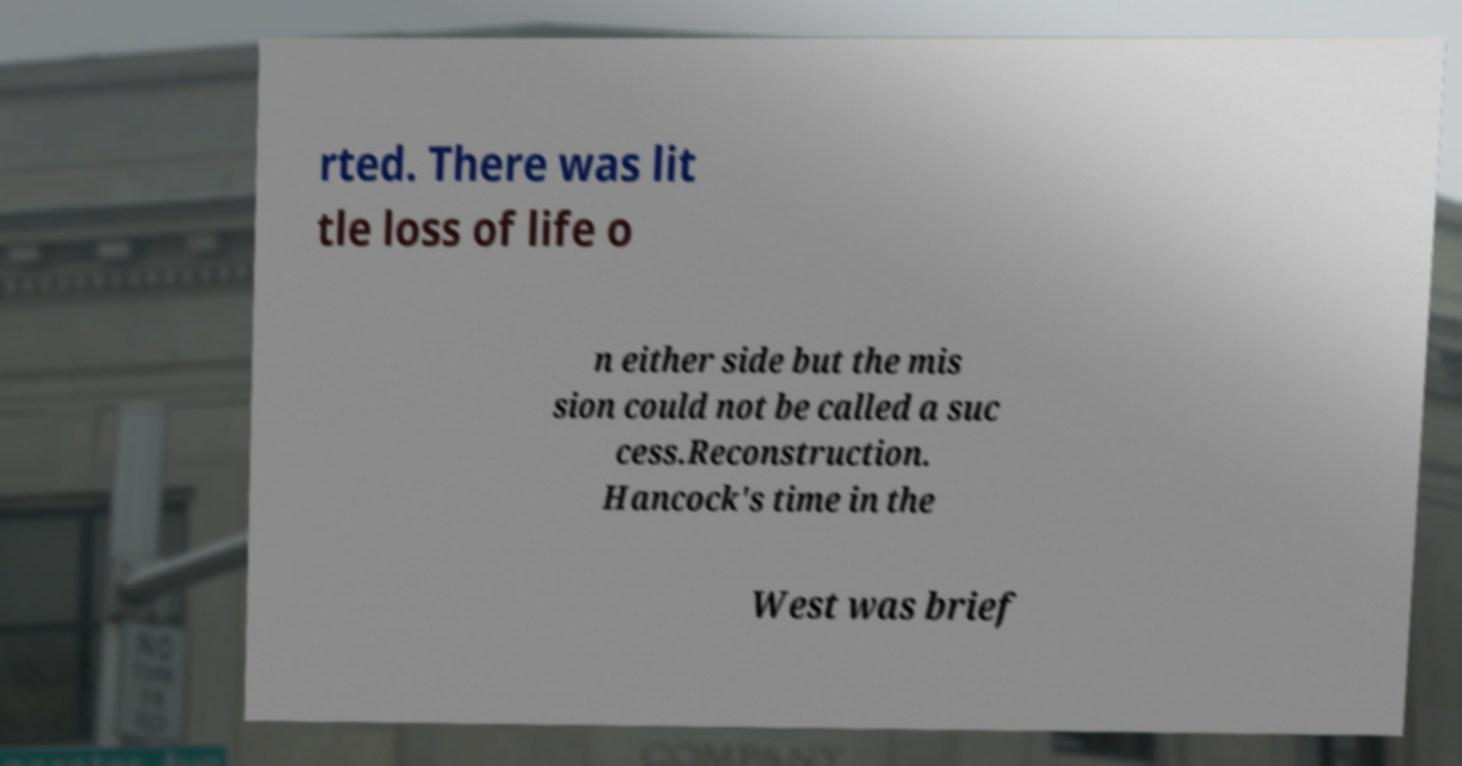Can you read and provide the text displayed in the image?This photo seems to have some interesting text. Can you extract and type it out for me? rted. There was lit tle loss of life o n either side but the mis sion could not be called a suc cess.Reconstruction. Hancock's time in the West was brief 